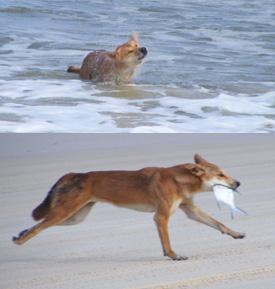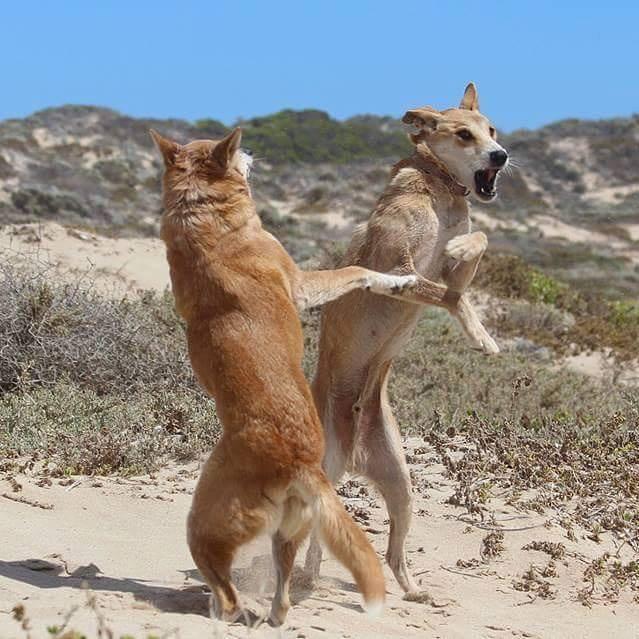The first image is the image on the left, the second image is the image on the right. Evaluate the accuracy of this statement regarding the images: "The right image contains a dog on the beach next to a dead shark.". Is it true? Answer yes or no. No. The first image is the image on the left, the second image is the image on the right. For the images displayed, is the sentence "An image shows a person in some pose to the right of a standing orange dog." factually correct? Answer yes or no. No. 